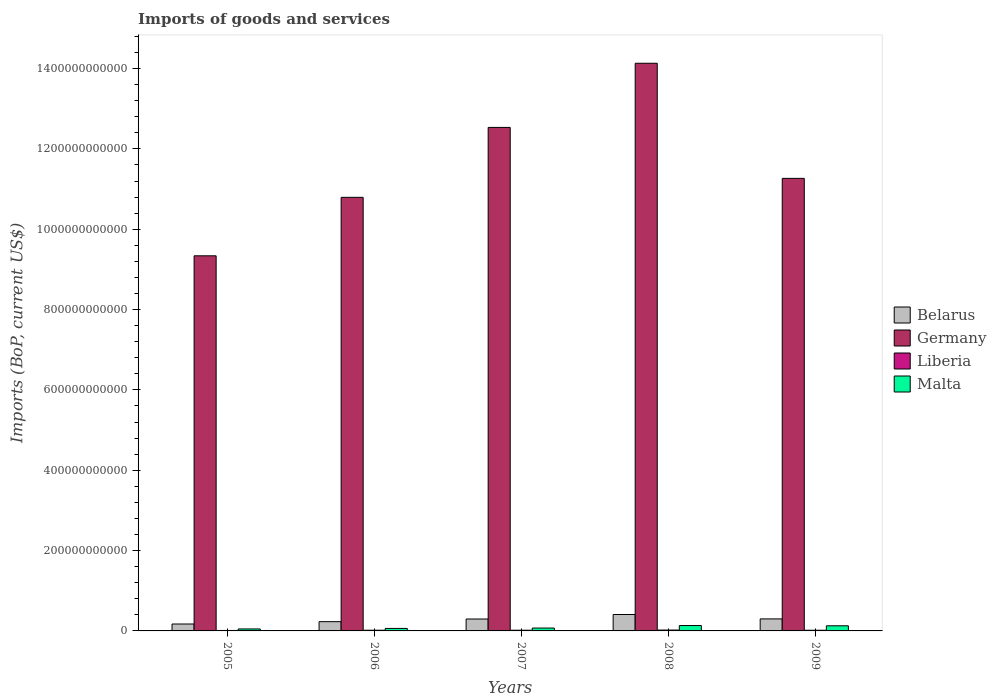How many bars are there on the 3rd tick from the left?
Ensure brevity in your answer.  4. How many bars are there on the 5th tick from the right?
Keep it short and to the point. 4. What is the label of the 3rd group of bars from the left?
Your answer should be compact. 2007. What is the amount spent on imports in Belarus in 2007?
Ensure brevity in your answer.  2.97e+1. Across all years, what is the maximum amount spent on imports in Liberia?
Ensure brevity in your answer.  2.14e+09. Across all years, what is the minimum amount spent on imports in Liberia?
Your answer should be compact. 1.16e+09. What is the total amount spent on imports in Liberia in the graph?
Your response must be concise. 8.47e+09. What is the difference between the amount spent on imports in Liberia in 2007 and that in 2009?
Your answer should be very brief. 4.31e+07. What is the difference between the amount spent on imports in Malta in 2008 and the amount spent on imports in Liberia in 2009?
Provide a short and direct response. 1.17e+1. What is the average amount spent on imports in Germany per year?
Your answer should be very brief. 1.16e+12. In the year 2008, what is the difference between the amount spent on imports in Liberia and amount spent on imports in Germany?
Your response must be concise. -1.41e+12. What is the ratio of the amount spent on imports in Malta in 2005 to that in 2008?
Keep it short and to the point. 0.37. Is the amount spent on imports in Malta in 2007 less than that in 2009?
Give a very brief answer. Yes. Is the difference between the amount spent on imports in Liberia in 2005 and 2009 greater than the difference between the amount spent on imports in Germany in 2005 and 2009?
Your response must be concise. Yes. What is the difference between the highest and the second highest amount spent on imports in Belarus?
Your answer should be very brief. 1.10e+1. What is the difference between the highest and the lowest amount spent on imports in Germany?
Provide a succinct answer. 4.79e+11. Is the sum of the amount spent on imports in Malta in 2006 and 2007 greater than the maximum amount spent on imports in Germany across all years?
Offer a terse response. No. What does the 2nd bar from the left in 2009 represents?
Keep it short and to the point. Germany. What does the 4th bar from the right in 2006 represents?
Your answer should be compact. Belarus. Is it the case that in every year, the sum of the amount spent on imports in Germany and amount spent on imports in Belarus is greater than the amount spent on imports in Liberia?
Your answer should be compact. Yes. How many bars are there?
Offer a terse response. 20. Are all the bars in the graph horizontal?
Your response must be concise. No. How many years are there in the graph?
Give a very brief answer. 5. What is the difference between two consecutive major ticks on the Y-axis?
Your answer should be very brief. 2.00e+11. Does the graph contain grids?
Give a very brief answer. No. Where does the legend appear in the graph?
Offer a terse response. Center right. How many legend labels are there?
Make the answer very short. 4. What is the title of the graph?
Keep it short and to the point. Imports of goods and services. Does "Australia" appear as one of the legend labels in the graph?
Your response must be concise. No. What is the label or title of the Y-axis?
Your answer should be very brief. Imports (BoP, current US$). What is the Imports (BoP, current US$) of Belarus in 2005?
Give a very brief answer. 1.72e+1. What is the Imports (BoP, current US$) of Germany in 2005?
Provide a short and direct response. 9.34e+11. What is the Imports (BoP, current US$) in Liberia in 2005?
Make the answer very short. 1.16e+09. What is the Imports (BoP, current US$) of Malta in 2005?
Your answer should be very brief. 4.91e+09. What is the Imports (BoP, current US$) of Belarus in 2006?
Your response must be concise. 2.31e+1. What is the Imports (BoP, current US$) of Germany in 2006?
Your answer should be compact. 1.08e+12. What is the Imports (BoP, current US$) of Liberia in 2006?
Make the answer very short. 1.72e+09. What is the Imports (BoP, current US$) in Malta in 2006?
Provide a succinct answer. 6.21e+09. What is the Imports (BoP, current US$) in Belarus in 2007?
Your answer should be very brief. 2.97e+1. What is the Imports (BoP, current US$) of Germany in 2007?
Provide a succinct answer. 1.25e+12. What is the Imports (BoP, current US$) of Liberia in 2007?
Ensure brevity in your answer.  1.75e+09. What is the Imports (BoP, current US$) of Malta in 2007?
Your answer should be very brief. 7.16e+09. What is the Imports (BoP, current US$) in Belarus in 2008?
Your response must be concise. 4.09e+1. What is the Imports (BoP, current US$) in Germany in 2008?
Offer a terse response. 1.41e+12. What is the Imports (BoP, current US$) of Liberia in 2008?
Your answer should be very brief. 2.14e+09. What is the Imports (BoP, current US$) in Malta in 2008?
Keep it short and to the point. 1.34e+1. What is the Imports (BoP, current US$) of Belarus in 2009?
Your response must be concise. 2.99e+1. What is the Imports (BoP, current US$) in Germany in 2009?
Provide a succinct answer. 1.13e+12. What is the Imports (BoP, current US$) in Liberia in 2009?
Make the answer very short. 1.70e+09. What is the Imports (BoP, current US$) of Malta in 2009?
Provide a short and direct response. 1.28e+1. Across all years, what is the maximum Imports (BoP, current US$) in Belarus?
Provide a short and direct response. 4.09e+1. Across all years, what is the maximum Imports (BoP, current US$) in Germany?
Your response must be concise. 1.41e+12. Across all years, what is the maximum Imports (BoP, current US$) in Liberia?
Your response must be concise. 2.14e+09. Across all years, what is the maximum Imports (BoP, current US$) in Malta?
Keep it short and to the point. 1.34e+1. Across all years, what is the minimum Imports (BoP, current US$) of Belarus?
Offer a terse response. 1.72e+1. Across all years, what is the minimum Imports (BoP, current US$) of Germany?
Provide a succinct answer. 9.34e+11. Across all years, what is the minimum Imports (BoP, current US$) of Liberia?
Make the answer very short. 1.16e+09. Across all years, what is the minimum Imports (BoP, current US$) in Malta?
Keep it short and to the point. 4.91e+09. What is the total Imports (BoP, current US$) in Belarus in the graph?
Keep it short and to the point. 1.41e+11. What is the total Imports (BoP, current US$) in Germany in the graph?
Provide a succinct answer. 5.81e+12. What is the total Imports (BoP, current US$) of Liberia in the graph?
Make the answer very short. 8.47e+09. What is the total Imports (BoP, current US$) of Malta in the graph?
Offer a terse response. 4.45e+1. What is the difference between the Imports (BoP, current US$) in Belarus in 2005 and that in 2006?
Your response must be concise. -5.87e+09. What is the difference between the Imports (BoP, current US$) in Germany in 2005 and that in 2006?
Your answer should be very brief. -1.46e+11. What is the difference between the Imports (BoP, current US$) of Liberia in 2005 and that in 2006?
Make the answer very short. -5.54e+08. What is the difference between the Imports (BoP, current US$) in Malta in 2005 and that in 2006?
Offer a very short reply. -1.30e+09. What is the difference between the Imports (BoP, current US$) of Belarus in 2005 and that in 2007?
Keep it short and to the point. -1.25e+1. What is the difference between the Imports (BoP, current US$) of Germany in 2005 and that in 2007?
Provide a short and direct response. -3.20e+11. What is the difference between the Imports (BoP, current US$) of Liberia in 2005 and that in 2007?
Offer a very short reply. -5.85e+08. What is the difference between the Imports (BoP, current US$) of Malta in 2005 and that in 2007?
Provide a succinct answer. -2.25e+09. What is the difference between the Imports (BoP, current US$) of Belarus in 2005 and that in 2008?
Offer a terse response. -2.37e+1. What is the difference between the Imports (BoP, current US$) in Germany in 2005 and that in 2008?
Your answer should be very brief. -4.79e+11. What is the difference between the Imports (BoP, current US$) in Liberia in 2005 and that in 2008?
Offer a terse response. -9.78e+08. What is the difference between the Imports (BoP, current US$) in Malta in 2005 and that in 2008?
Provide a succinct answer. -8.49e+09. What is the difference between the Imports (BoP, current US$) in Belarus in 2005 and that in 2009?
Give a very brief answer. -1.27e+1. What is the difference between the Imports (BoP, current US$) of Germany in 2005 and that in 2009?
Your response must be concise. -1.93e+11. What is the difference between the Imports (BoP, current US$) of Liberia in 2005 and that in 2009?
Ensure brevity in your answer.  -5.42e+08. What is the difference between the Imports (BoP, current US$) in Malta in 2005 and that in 2009?
Ensure brevity in your answer.  -7.86e+09. What is the difference between the Imports (BoP, current US$) in Belarus in 2006 and that in 2007?
Provide a short and direct response. -6.61e+09. What is the difference between the Imports (BoP, current US$) in Germany in 2006 and that in 2007?
Provide a short and direct response. -1.74e+11. What is the difference between the Imports (BoP, current US$) of Liberia in 2006 and that in 2007?
Offer a terse response. -3.16e+07. What is the difference between the Imports (BoP, current US$) of Malta in 2006 and that in 2007?
Provide a short and direct response. -9.52e+08. What is the difference between the Imports (BoP, current US$) in Belarus in 2006 and that in 2008?
Ensure brevity in your answer.  -1.78e+1. What is the difference between the Imports (BoP, current US$) in Germany in 2006 and that in 2008?
Your answer should be compact. -3.34e+11. What is the difference between the Imports (BoP, current US$) in Liberia in 2006 and that in 2008?
Make the answer very short. -4.24e+08. What is the difference between the Imports (BoP, current US$) in Malta in 2006 and that in 2008?
Keep it short and to the point. -7.19e+09. What is the difference between the Imports (BoP, current US$) of Belarus in 2006 and that in 2009?
Provide a succinct answer. -6.86e+09. What is the difference between the Imports (BoP, current US$) in Germany in 2006 and that in 2009?
Provide a short and direct response. -4.72e+1. What is the difference between the Imports (BoP, current US$) in Liberia in 2006 and that in 2009?
Your response must be concise. 1.16e+07. What is the difference between the Imports (BoP, current US$) in Malta in 2006 and that in 2009?
Your response must be concise. -6.56e+09. What is the difference between the Imports (BoP, current US$) in Belarus in 2007 and that in 2008?
Ensure brevity in your answer.  -1.12e+1. What is the difference between the Imports (BoP, current US$) in Germany in 2007 and that in 2008?
Your answer should be very brief. -1.60e+11. What is the difference between the Imports (BoP, current US$) in Liberia in 2007 and that in 2008?
Ensure brevity in your answer.  -3.93e+08. What is the difference between the Imports (BoP, current US$) in Malta in 2007 and that in 2008?
Make the answer very short. -6.24e+09. What is the difference between the Imports (BoP, current US$) of Belarus in 2007 and that in 2009?
Offer a very short reply. -2.49e+08. What is the difference between the Imports (BoP, current US$) of Germany in 2007 and that in 2009?
Your response must be concise. 1.27e+11. What is the difference between the Imports (BoP, current US$) in Liberia in 2007 and that in 2009?
Keep it short and to the point. 4.31e+07. What is the difference between the Imports (BoP, current US$) of Malta in 2007 and that in 2009?
Provide a succinct answer. -5.61e+09. What is the difference between the Imports (BoP, current US$) in Belarus in 2008 and that in 2009?
Your answer should be very brief. 1.10e+1. What is the difference between the Imports (BoP, current US$) of Germany in 2008 and that in 2009?
Keep it short and to the point. 2.87e+11. What is the difference between the Imports (BoP, current US$) of Liberia in 2008 and that in 2009?
Keep it short and to the point. 4.36e+08. What is the difference between the Imports (BoP, current US$) in Malta in 2008 and that in 2009?
Your response must be concise. 6.31e+08. What is the difference between the Imports (BoP, current US$) in Belarus in 2005 and the Imports (BoP, current US$) in Germany in 2006?
Your response must be concise. -1.06e+12. What is the difference between the Imports (BoP, current US$) of Belarus in 2005 and the Imports (BoP, current US$) of Liberia in 2006?
Provide a short and direct response. 1.55e+1. What is the difference between the Imports (BoP, current US$) in Belarus in 2005 and the Imports (BoP, current US$) in Malta in 2006?
Provide a succinct answer. 1.10e+1. What is the difference between the Imports (BoP, current US$) of Germany in 2005 and the Imports (BoP, current US$) of Liberia in 2006?
Keep it short and to the point. 9.32e+11. What is the difference between the Imports (BoP, current US$) of Germany in 2005 and the Imports (BoP, current US$) of Malta in 2006?
Provide a short and direct response. 9.28e+11. What is the difference between the Imports (BoP, current US$) of Liberia in 2005 and the Imports (BoP, current US$) of Malta in 2006?
Keep it short and to the point. -5.05e+09. What is the difference between the Imports (BoP, current US$) of Belarus in 2005 and the Imports (BoP, current US$) of Germany in 2007?
Keep it short and to the point. -1.24e+12. What is the difference between the Imports (BoP, current US$) of Belarus in 2005 and the Imports (BoP, current US$) of Liberia in 2007?
Ensure brevity in your answer.  1.54e+1. What is the difference between the Imports (BoP, current US$) of Belarus in 2005 and the Imports (BoP, current US$) of Malta in 2007?
Offer a very short reply. 1.00e+1. What is the difference between the Imports (BoP, current US$) of Germany in 2005 and the Imports (BoP, current US$) of Liberia in 2007?
Ensure brevity in your answer.  9.32e+11. What is the difference between the Imports (BoP, current US$) in Germany in 2005 and the Imports (BoP, current US$) in Malta in 2007?
Your response must be concise. 9.27e+11. What is the difference between the Imports (BoP, current US$) of Liberia in 2005 and the Imports (BoP, current US$) of Malta in 2007?
Provide a succinct answer. -6.00e+09. What is the difference between the Imports (BoP, current US$) in Belarus in 2005 and the Imports (BoP, current US$) in Germany in 2008?
Make the answer very short. -1.40e+12. What is the difference between the Imports (BoP, current US$) of Belarus in 2005 and the Imports (BoP, current US$) of Liberia in 2008?
Make the answer very short. 1.51e+1. What is the difference between the Imports (BoP, current US$) in Belarus in 2005 and the Imports (BoP, current US$) in Malta in 2008?
Offer a very short reply. 3.80e+09. What is the difference between the Imports (BoP, current US$) in Germany in 2005 and the Imports (BoP, current US$) in Liberia in 2008?
Your response must be concise. 9.32e+11. What is the difference between the Imports (BoP, current US$) of Germany in 2005 and the Imports (BoP, current US$) of Malta in 2008?
Your answer should be very brief. 9.20e+11. What is the difference between the Imports (BoP, current US$) in Liberia in 2005 and the Imports (BoP, current US$) in Malta in 2008?
Keep it short and to the point. -1.22e+1. What is the difference between the Imports (BoP, current US$) in Belarus in 2005 and the Imports (BoP, current US$) in Germany in 2009?
Give a very brief answer. -1.11e+12. What is the difference between the Imports (BoP, current US$) in Belarus in 2005 and the Imports (BoP, current US$) in Liberia in 2009?
Offer a terse response. 1.55e+1. What is the difference between the Imports (BoP, current US$) in Belarus in 2005 and the Imports (BoP, current US$) in Malta in 2009?
Your answer should be very brief. 4.43e+09. What is the difference between the Imports (BoP, current US$) of Germany in 2005 and the Imports (BoP, current US$) of Liberia in 2009?
Provide a short and direct response. 9.32e+11. What is the difference between the Imports (BoP, current US$) in Germany in 2005 and the Imports (BoP, current US$) in Malta in 2009?
Your answer should be compact. 9.21e+11. What is the difference between the Imports (BoP, current US$) of Liberia in 2005 and the Imports (BoP, current US$) of Malta in 2009?
Your answer should be compact. -1.16e+1. What is the difference between the Imports (BoP, current US$) in Belarus in 2006 and the Imports (BoP, current US$) in Germany in 2007?
Your answer should be very brief. -1.23e+12. What is the difference between the Imports (BoP, current US$) in Belarus in 2006 and the Imports (BoP, current US$) in Liberia in 2007?
Your response must be concise. 2.13e+1. What is the difference between the Imports (BoP, current US$) in Belarus in 2006 and the Imports (BoP, current US$) in Malta in 2007?
Your response must be concise. 1.59e+1. What is the difference between the Imports (BoP, current US$) of Germany in 2006 and the Imports (BoP, current US$) of Liberia in 2007?
Provide a succinct answer. 1.08e+12. What is the difference between the Imports (BoP, current US$) of Germany in 2006 and the Imports (BoP, current US$) of Malta in 2007?
Your answer should be compact. 1.07e+12. What is the difference between the Imports (BoP, current US$) in Liberia in 2006 and the Imports (BoP, current US$) in Malta in 2007?
Give a very brief answer. -5.45e+09. What is the difference between the Imports (BoP, current US$) of Belarus in 2006 and the Imports (BoP, current US$) of Germany in 2008?
Offer a very short reply. -1.39e+12. What is the difference between the Imports (BoP, current US$) of Belarus in 2006 and the Imports (BoP, current US$) of Liberia in 2008?
Provide a short and direct response. 2.09e+1. What is the difference between the Imports (BoP, current US$) in Belarus in 2006 and the Imports (BoP, current US$) in Malta in 2008?
Ensure brevity in your answer.  9.66e+09. What is the difference between the Imports (BoP, current US$) in Germany in 2006 and the Imports (BoP, current US$) in Liberia in 2008?
Make the answer very short. 1.08e+12. What is the difference between the Imports (BoP, current US$) of Germany in 2006 and the Imports (BoP, current US$) of Malta in 2008?
Your response must be concise. 1.07e+12. What is the difference between the Imports (BoP, current US$) of Liberia in 2006 and the Imports (BoP, current US$) of Malta in 2008?
Ensure brevity in your answer.  -1.17e+1. What is the difference between the Imports (BoP, current US$) of Belarus in 2006 and the Imports (BoP, current US$) of Germany in 2009?
Offer a terse response. -1.10e+12. What is the difference between the Imports (BoP, current US$) of Belarus in 2006 and the Imports (BoP, current US$) of Liberia in 2009?
Your answer should be very brief. 2.14e+1. What is the difference between the Imports (BoP, current US$) in Belarus in 2006 and the Imports (BoP, current US$) in Malta in 2009?
Give a very brief answer. 1.03e+1. What is the difference between the Imports (BoP, current US$) of Germany in 2006 and the Imports (BoP, current US$) of Liberia in 2009?
Give a very brief answer. 1.08e+12. What is the difference between the Imports (BoP, current US$) of Germany in 2006 and the Imports (BoP, current US$) of Malta in 2009?
Provide a short and direct response. 1.07e+12. What is the difference between the Imports (BoP, current US$) of Liberia in 2006 and the Imports (BoP, current US$) of Malta in 2009?
Your answer should be very brief. -1.11e+1. What is the difference between the Imports (BoP, current US$) of Belarus in 2007 and the Imports (BoP, current US$) of Germany in 2008?
Keep it short and to the point. -1.38e+12. What is the difference between the Imports (BoP, current US$) of Belarus in 2007 and the Imports (BoP, current US$) of Liberia in 2008?
Offer a terse response. 2.75e+1. What is the difference between the Imports (BoP, current US$) in Belarus in 2007 and the Imports (BoP, current US$) in Malta in 2008?
Your response must be concise. 1.63e+1. What is the difference between the Imports (BoP, current US$) in Germany in 2007 and the Imports (BoP, current US$) in Liberia in 2008?
Keep it short and to the point. 1.25e+12. What is the difference between the Imports (BoP, current US$) in Germany in 2007 and the Imports (BoP, current US$) in Malta in 2008?
Make the answer very short. 1.24e+12. What is the difference between the Imports (BoP, current US$) of Liberia in 2007 and the Imports (BoP, current US$) of Malta in 2008?
Your response must be concise. -1.17e+1. What is the difference between the Imports (BoP, current US$) of Belarus in 2007 and the Imports (BoP, current US$) of Germany in 2009?
Ensure brevity in your answer.  -1.10e+12. What is the difference between the Imports (BoP, current US$) of Belarus in 2007 and the Imports (BoP, current US$) of Liberia in 2009?
Give a very brief answer. 2.80e+1. What is the difference between the Imports (BoP, current US$) of Belarus in 2007 and the Imports (BoP, current US$) of Malta in 2009?
Give a very brief answer. 1.69e+1. What is the difference between the Imports (BoP, current US$) in Germany in 2007 and the Imports (BoP, current US$) in Liberia in 2009?
Provide a short and direct response. 1.25e+12. What is the difference between the Imports (BoP, current US$) of Germany in 2007 and the Imports (BoP, current US$) of Malta in 2009?
Give a very brief answer. 1.24e+12. What is the difference between the Imports (BoP, current US$) in Liberia in 2007 and the Imports (BoP, current US$) in Malta in 2009?
Your answer should be compact. -1.10e+1. What is the difference between the Imports (BoP, current US$) in Belarus in 2008 and the Imports (BoP, current US$) in Germany in 2009?
Make the answer very short. -1.09e+12. What is the difference between the Imports (BoP, current US$) of Belarus in 2008 and the Imports (BoP, current US$) of Liberia in 2009?
Provide a succinct answer. 3.92e+1. What is the difference between the Imports (BoP, current US$) of Belarus in 2008 and the Imports (BoP, current US$) of Malta in 2009?
Provide a succinct answer. 2.81e+1. What is the difference between the Imports (BoP, current US$) in Germany in 2008 and the Imports (BoP, current US$) in Liberia in 2009?
Ensure brevity in your answer.  1.41e+12. What is the difference between the Imports (BoP, current US$) of Germany in 2008 and the Imports (BoP, current US$) of Malta in 2009?
Offer a terse response. 1.40e+12. What is the difference between the Imports (BoP, current US$) in Liberia in 2008 and the Imports (BoP, current US$) in Malta in 2009?
Your answer should be compact. -1.06e+1. What is the average Imports (BoP, current US$) of Belarus per year?
Ensure brevity in your answer.  2.81e+1. What is the average Imports (BoP, current US$) in Germany per year?
Your answer should be compact. 1.16e+12. What is the average Imports (BoP, current US$) in Liberia per year?
Your answer should be very brief. 1.69e+09. What is the average Imports (BoP, current US$) of Malta per year?
Offer a very short reply. 8.89e+09. In the year 2005, what is the difference between the Imports (BoP, current US$) of Belarus and Imports (BoP, current US$) of Germany?
Offer a terse response. -9.17e+11. In the year 2005, what is the difference between the Imports (BoP, current US$) in Belarus and Imports (BoP, current US$) in Liberia?
Offer a terse response. 1.60e+1. In the year 2005, what is the difference between the Imports (BoP, current US$) in Belarus and Imports (BoP, current US$) in Malta?
Make the answer very short. 1.23e+1. In the year 2005, what is the difference between the Imports (BoP, current US$) in Germany and Imports (BoP, current US$) in Liberia?
Ensure brevity in your answer.  9.33e+11. In the year 2005, what is the difference between the Imports (BoP, current US$) in Germany and Imports (BoP, current US$) in Malta?
Ensure brevity in your answer.  9.29e+11. In the year 2005, what is the difference between the Imports (BoP, current US$) in Liberia and Imports (BoP, current US$) in Malta?
Offer a terse response. -3.75e+09. In the year 2006, what is the difference between the Imports (BoP, current US$) of Belarus and Imports (BoP, current US$) of Germany?
Give a very brief answer. -1.06e+12. In the year 2006, what is the difference between the Imports (BoP, current US$) in Belarus and Imports (BoP, current US$) in Liberia?
Your answer should be very brief. 2.13e+1. In the year 2006, what is the difference between the Imports (BoP, current US$) in Belarus and Imports (BoP, current US$) in Malta?
Provide a succinct answer. 1.69e+1. In the year 2006, what is the difference between the Imports (BoP, current US$) in Germany and Imports (BoP, current US$) in Liberia?
Offer a very short reply. 1.08e+12. In the year 2006, what is the difference between the Imports (BoP, current US$) in Germany and Imports (BoP, current US$) in Malta?
Keep it short and to the point. 1.07e+12. In the year 2006, what is the difference between the Imports (BoP, current US$) in Liberia and Imports (BoP, current US$) in Malta?
Make the answer very short. -4.49e+09. In the year 2007, what is the difference between the Imports (BoP, current US$) in Belarus and Imports (BoP, current US$) in Germany?
Make the answer very short. -1.22e+12. In the year 2007, what is the difference between the Imports (BoP, current US$) in Belarus and Imports (BoP, current US$) in Liberia?
Offer a very short reply. 2.79e+1. In the year 2007, what is the difference between the Imports (BoP, current US$) in Belarus and Imports (BoP, current US$) in Malta?
Your response must be concise. 2.25e+1. In the year 2007, what is the difference between the Imports (BoP, current US$) of Germany and Imports (BoP, current US$) of Liberia?
Provide a succinct answer. 1.25e+12. In the year 2007, what is the difference between the Imports (BoP, current US$) in Germany and Imports (BoP, current US$) in Malta?
Make the answer very short. 1.25e+12. In the year 2007, what is the difference between the Imports (BoP, current US$) in Liberia and Imports (BoP, current US$) in Malta?
Offer a terse response. -5.41e+09. In the year 2008, what is the difference between the Imports (BoP, current US$) of Belarus and Imports (BoP, current US$) of Germany?
Offer a terse response. -1.37e+12. In the year 2008, what is the difference between the Imports (BoP, current US$) of Belarus and Imports (BoP, current US$) of Liberia?
Your answer should be very brief. 3.87e+1. In the year 2008, what is the difference between the Imports (BoP, current US$) in Belarus and Imports (BoP, current US$) in Malta?
Offer a very short reply. 2.75e+1. In the year 2008, what is the difference between the Imports (BoP, current US$) in Germany and Imports (BoP, current US$) in Liberia?
Offer a terse response. 1.41e+12. In the year 2008, what is the difference between the Imports (BoP, current US$) in Germany and Imports (BoP, current US$) in Malta?
Offer a terse response. 1.40e+12. In the year 2008, what is the difference between the Imports (BoP, current US$) in Liberia and Imports (BoP, current US$) in Malta?
Ensure brevity in your answer.  -1.13e+1. In the year 2009, what is the difference between the Imports (BoP, current US$) in Belarus and Imports (BoP, current US$) in Germany?
Give a very brief answer. -1.10e+12. In the year 2009, what is the difference between the Imports (BoP, current US$) of Belarus and Imports (BoP, current US$) of Liberia?
Provide a short and direct response. 2.82e+1. In the year 2009, what is the difference between the Imports (BoP, current US$) of Belarus and Imports (BoP, current US$) of Malta?
Give a very brief answer. 1.72e+1. In the year 2009, what is the difference between the Imports (BoP, current US$) of Germany and Imports (BoP, current US$) of Liberia?
Offer a very short reply. 1.12e+12. In the year 2009, what is the difference between the Imports (BoP, current US$) in Germany and Imports (BoP, current US$) in Malta?
Your response must be concise. 1.11e+12. In the year 2009, what is the difference between the Imports (BoP, current US$) in Liberia and Imports (BoP, current US$) in Malta?
Provide a short and direct response. -1.11e+1. What is the ratio of the Imports (BoP, current US$) in Belarus in 2005 to that in 2006?
Offer a very short reply. 0.75. What is the ratio of the Imports (BoP, current US$) in Germany in 2005 to that in 2006?
Make the answer very short. 0.87. What is the ratio of the Imports (BoP, current US$) of Liberia in 2005 to that in 2006?
Ensure brevity in your answer.  0.68. What is the ratio of the Imports (BoP, current US$) in Malta in 2005 to that in 2006?
Your answer should be compact. 0.79. What is the ratio of the Imports (BoP, current US$) in Belarus in 2005 to that in 2007?
Provide a short and direct response. 0.58. What is the ratio of the Imports (BoP, current US$) in Germany in 2005 to that in 2007?
Give a very brief answer. 0.74. What is the ratio of the Imports (BoP, current US$) in Liberia in 2005 to that in 2007?
Make the answer very short. 0.66. What is the ratio of the Imports (BoP, current US$) of Malta in 2005 to that in 2007?
Make the answer very short. 0.69. What is the ratio of the Imports (BoP, current US$) of Belarus in 2005 to that in 2008?
Your answer should be compact. 0.42. What is the ratio of the Imports (BoP, current US$) of Germany in 2005 to that in 2008?
Give a very brief answer. 0.66. What is the ratio of the Imports (BoP, current US$) of Liberia in 2005 to that in 2008?
Your answer should be very brief. 0.54. What is the ratio of the Imports (BoP, current US$) in Malta in 2005 to that in 2008?
Your response must be concise. 0.37. What is the ratio of the Imports (BoP, current US$) in Belarus in 2005 to that in 2009?
Your answer should be very brief. 0.57. What is the ratio of the Imports (BoP, current US$) of Germany in 2005 to that in 2009?
Your response must be concise. 0.83. What is the ratio of the Imports (BoP, current US$) of Liberia in 2005 to that in 2009?
Your answer should be compact. 0.68. What is the ratio of the Imports (BoP, current US$) in Malta in 2005 to that in 2009?
Provide a succinct answer. 0.38. What is the ratio of the Imports (BoP, current US$) of Belarus in 2006 to that in 2007?
Provide a short and direct response. 0.78. What is the ratio of the Imports (BoP, current US$) in Germany in 2006 to that in 2007?
Provide a succinct answer. 0.86. What is the ratio of the Imports (BoP, current US$) of Liberia in 2006 to that in 2007?
Keep it short and to the point. 0.98. What is the ratio of the Imports (BoP, current US$) of Malta in 2006 to that in 2007?
Provide a succinct answer. 0.87. What is the ratio of the Imports (BoP, current US$) of Belarus in 2006 to that in 2008?
Ensure brevity in your answer.  0.56. What is the ratio of the Imports (BoP, current US$) of Germany in 2006 to that in 2008?
Your response must be concise. 0.76. What is the ratio of the Imports (BoP, current US$) of Liberia in 2006 to that in 2008?
Your answer should be compact. 0.8. What is the ratio of the Imports (BoP, current US$) in Malta in 2006 to that in 2008?
Keep it short and to the point. 0.46. What is the ratio of the Imports (BoP, current US$) in Belarus in 2006 to that in 2009?
Your answer should be very brief. 0.77. What is the ratio of the Imports (BoP, current US$) of Germany in 2006 to that in 2009?
Ensure brevity in your answer.  0.96. What is the ratio of the Imports (BoP, current US$) of Liberia in 2006 to that in 2009?
Your answer should be compact. 1.01. What is the ratio of the Imports (BoP, current US$) in Malta in 2006 to that in 2009?
Offer a very short reply. 0.49. What is the ratio of the Imports (BoP, current US$) of Belarus in 2007 to that in 2008?
Ensure brevity in your answer.  0.73. What is the ratio of the Imports (BoP, current US$) in Germany in 2007 to that in 2008?
Provide a short and direct response. 0.89. What is the ratio of the Imports (BoP, current US$) in Liberia in 2007 to that in 2008?
Offer a terse response. 0.82. What is the ratio of the Imports (BoP, current US$) in Malta in 2007 to that in 2008?
Make the answer very short. 0.53. What is the ratio of the Imports (BoP, current US$) in Germany in 2007 to that in 2009?
Your response must be concise. 1.11. What is the ratio of the Imports (BoP, current US$) in Liberia in 2007 to that in 2009?
Your response must be concise. 1.03. What is the ratio of the Imports (BoP, current US$) in Malta in 2007 to that in 2009?
Keep it short and to the point. 0.56. What is the ratio of the Imports (BoP, current US$) in Belarus in 2008 to that in 2009?
Provide a short and direct response. 1.37. What is the ratio of the Imports (BoP, current US$) of Germany in 2008 to that in 2009?
Give a very brief answer. 1.25. What is the ratio of the Imports (BoP, current US$) of Liberia in 2008 to that in 2009?
Your response must be concise. 1.26. What is the ratio of the Imports (BoP, current US$) in Malta in 2008 to that in 2009?
Provide a short and direct response. 1.05. What is the difference between the highest and the second highest Imports (BoP, current US$) of Belarus?
Your response must be concise. 1.10e+1. What is the difference between the highest and the second highest Imports (BoP, current US$) of Germany?
Keep it short and to the point. 1.60e+11. What is the difference between the highest and the second highest Imports (BoP, current US$) in Liberia?
Give a very brief answer. 3.93e+08. What is the difference between the highest and the second highest Imports (BoP, current US$) of Malta?
Offer a terse response. 6.31e+08. What is the difference between the highest and the lowest Imports (BoP, current US$) in Belarus?
Make the answer very short. 2.37e+1. What is the difference between the highest and the lowest Imports (BoP, current US$) of Germany?
Provide a succinct answer. 4.79e+11. What is the difference between the highest and the lowest Imports (BoP, current US$) of Liberia?
Give a very brief answer. 9.78e+08. What is the difference between the highest and the lowest Imports (BoP, current US$) in Malta?
Your answer should be compact. 8.49e+09. 